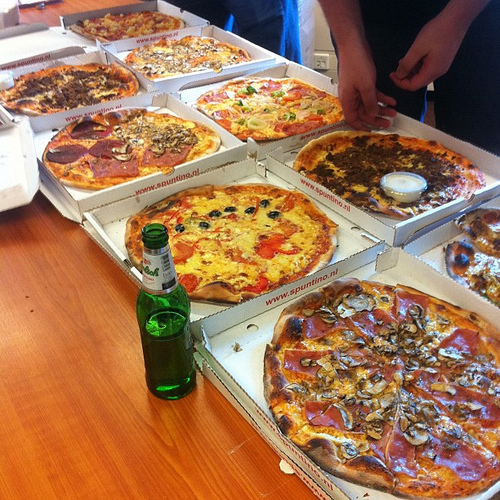Which color is the container that the cheese is in? The container that the cheese is in is white. 